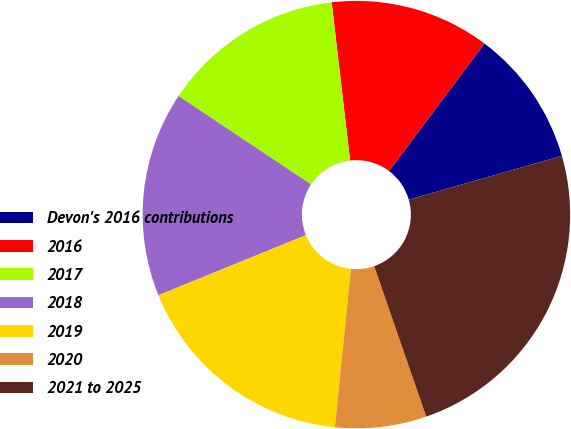<chart> <loc_0><loc_0><loc_500><loc_500><pie_chart><fcel>Devon's 2016 contributions<fcel>2016<fcel>2017<fcel>2018<fcel>2019<fcel>2020<fcel>2021 to 2025<nl><fcel>10.34%<fcel>12.07%<fcel>13.79%<fcel>15.52%<fcel>17.24%<fcel>6.9%<fcel>24.14%<nl></chart> 